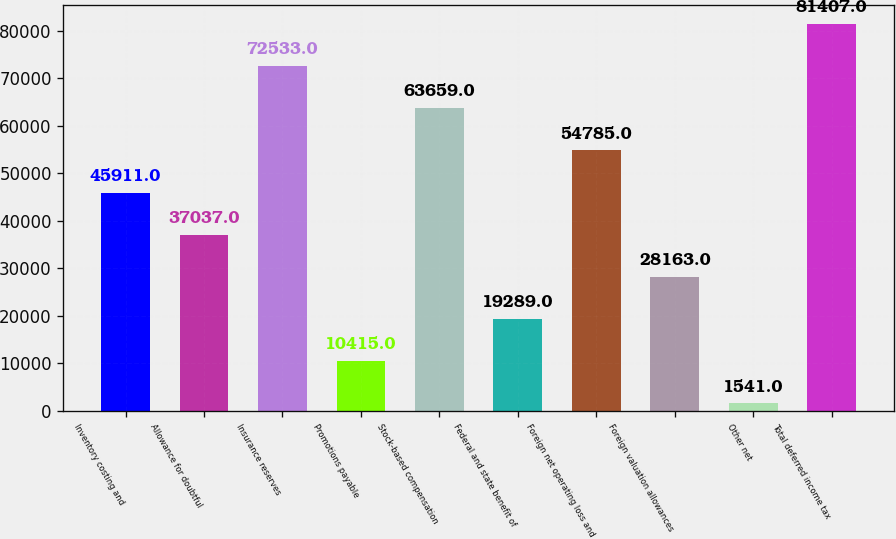Convert chart. <chart><loc_0><loc_0><loc_500><loc_500><bar_chart><fcel>Inventory costing and<fcel>Allowance for doubtful<fcel>Insurance reserves<fcel>Promotions payable<fcel>Stock-based compensation<fcel>Federal and state benefit of<fcel>Foreign net operating loss and<fcel>Foreign valuation allowances<fcel>Other net<fcel>Total deferred income tax<nl><fcel>45911<fcel>37037<fcel>72533<fcel>10415<fcel>63659<fcel>19289<fcel>54785<fcel>28163<fcel>1541<fcel>81407<nl></chart> 